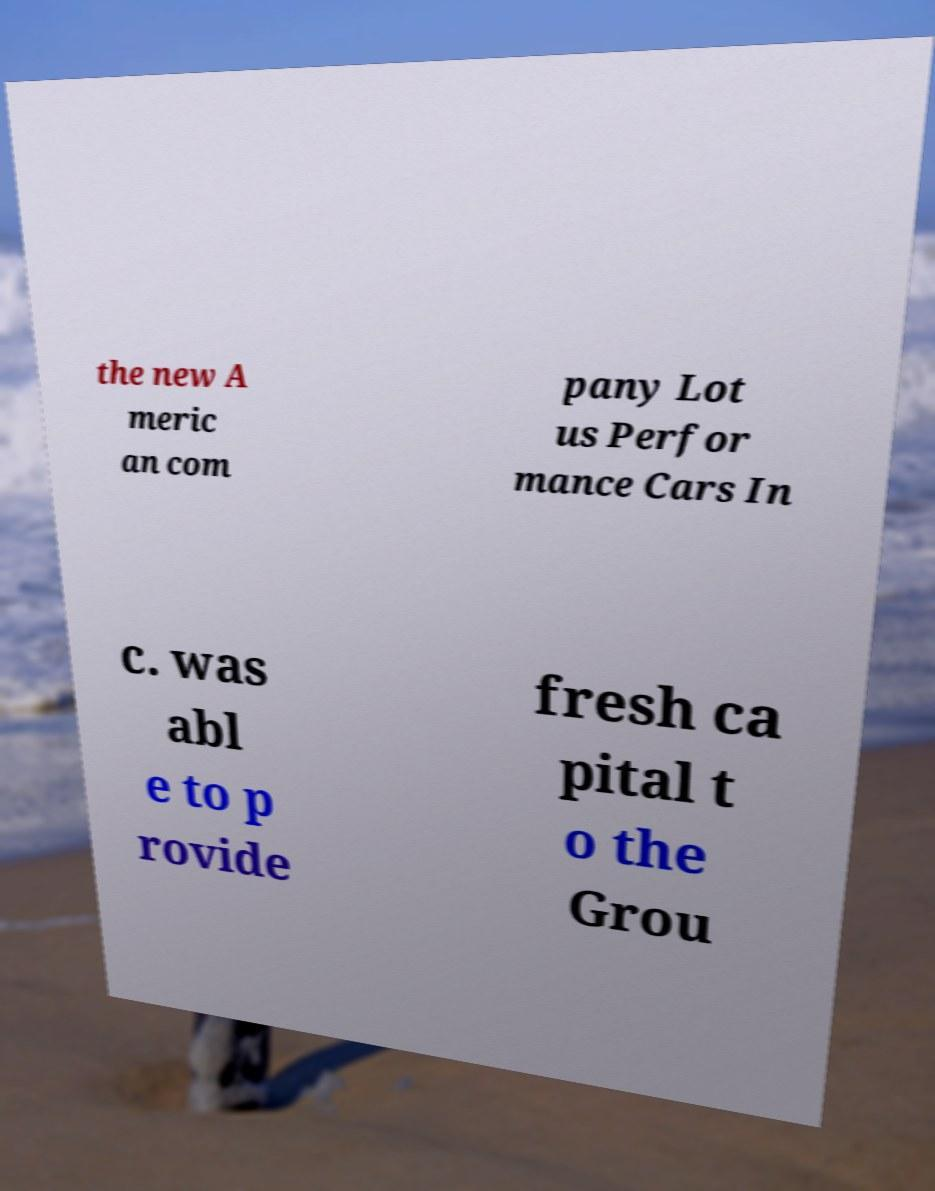For documentation purposes, I need the text within this image transcribed. Could you provide that? the new A meric an com pany Lot us Perfor mance Cars In c. was abl e to p rovide fresh ca pital t o the Grou 